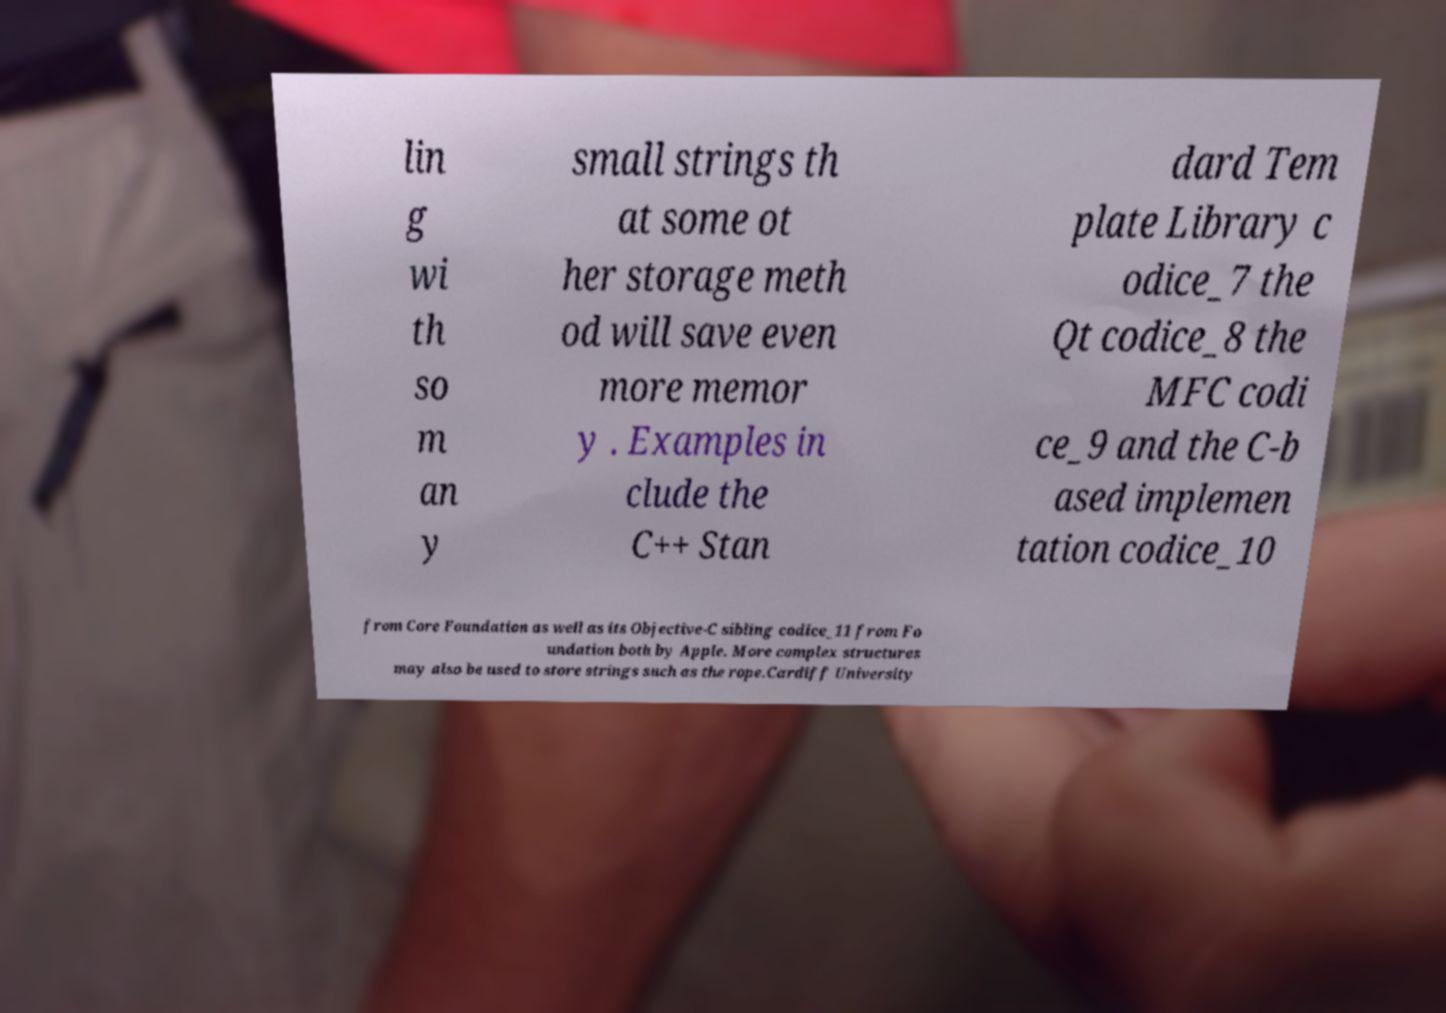Can you read and provide the text displayed in the image?This photo seems to have some interesting text. Can you extract and type it out for me? lin g wi th so m an y small strings th at some ot her storage meth od will save even more memor y . Examples in clude the C++ Stan dard Tem plate Library c odice_7 the Qt codice_8 the MFC codi ce_9 and the C-b ased implemen tation codice_10 from Core Foundation as well as its Objective-C sibling codice_11 from Fo undation both by Apple. More complex structures may also be used to store strings such as the rope.Cardiff University 